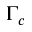Convert formula to latex. <formula><loc_0><loc_0><loc_500><loc_500>\Gamma _ { c }</formula> 